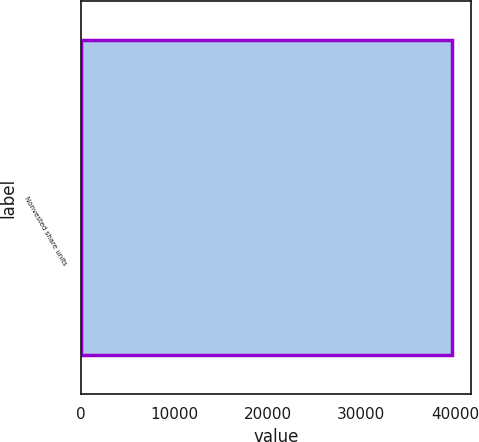Convert chart. <chart><loc_0><loc_0><loc_500><loc_500><bar_chart><fcel>Nonvested share units<nl><fcel>39747<nl></chart> 